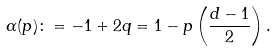Convert formula to latex. <formula><loc_0><loc_0><loc_500><loc_500>\alpha ( p ) \colon = - 1 + 2 q = 1 - p \left ( \frac { d - 1 } { 2 } \right ) .</formula> 